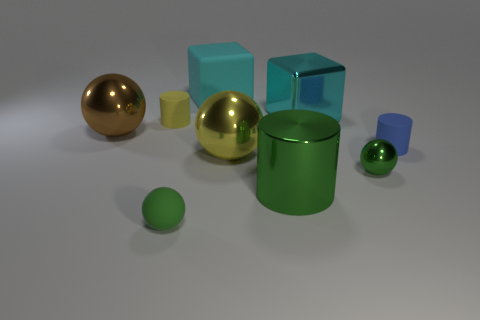The other metallic thing that is the same color as the tiny shiny object is what shape?
Your response must be concise. Cylinder. There is a matte cylinder that is the same size as the blue object; what is its color?
Offer a terse response. Yellow. Is the number of cyan rubber blocks that are behind the small blue rubber cylinder greater than the number of large spheres?
Your answer should be very brief. No. What is the material of the big thing that is both behind the small blue cylinder and in front of the cyan shiny cube?
Offer a terse response. Metal. Is the color of the matte object right of the shiny block the same as the metallic object behind the brown ball?
Offer a terse response. No. What number of other things are the same size as the matte cube?
Your answer should be very brief. 4. Are there any tiny metallic spheres that are in front of the ball left of the matte cylinder that is to the left of the tiny green rubber object?
Provide a short and direct response. Yes. Is the material of the cyan block left of the large cyan shiny object the same as the brown object?
Your response must be concise. No. What is the color of the other thing that is the same shape as the cyan rubber thing?
Offer a terse response. Cyan. Is there anything else that is the same shape as the large yellow thing?
Provide a short and direct response. Yes. 